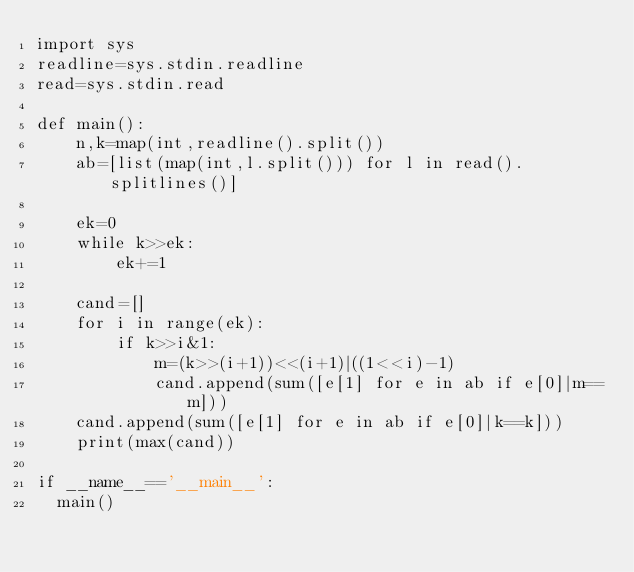<code> <loc_0><loc_0><loc_500><loc_500><_Python_>import sys
readline=sys.stdin.readline
read=sys.stdin.read

def main():
    n,k=map(int,readline().split())
    ab=[list(map(int,l.split())) for l in read().splitlines()]
    
    ek=0
    while k>>ek:
        ek+=1

    cand=[]
    for i in range(ek):
        if k>>i&1:
            m=(k>>(i+1))<<(i+1)|((1<<i)-1)
            cand.append(sum([e[1] for e in ab if e[0]|m==m]))
    cand.append(sum([e[1] for e in ab if e[0]|k==k]))
    print(max(cand))

if __name__=='__main__':
  main()
</code> 